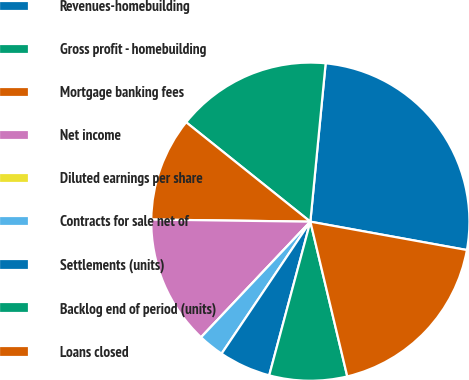Convert chart. <chart><loc_0><loc_0><loc_500><loc_500><pie_chart><fcel>Revenues-homebuilding<fcel>Gross profit - homebuilding<fcel>Mortgage banking fees<fcel>Net income<fcel>Diluted earnings per share<fcel>Contracts for sale net of<fcel>Settlements (units)<fcel>Backlog end of period (units)<fcel>Loans closed<nl><fcel>26.32%<fcel>15.79%<fcel>10.53%<fcel>13.16%<fcel>0.0%<fcel>2.63%<fcel>5.26%<fcel>7.89%<fcel>18.42%<nl></chart> 